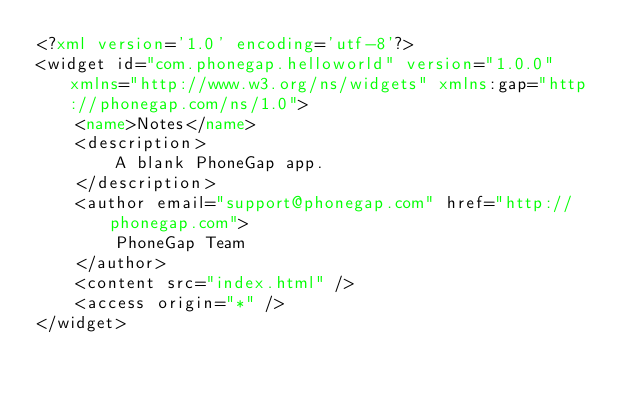Convert code to text. <code><loc_0><loc_0><loc_500><loc_500><_XML_><?xml version='1.0' encoding='utf-8'?>
<widget id="com.phonegap.helloworld" version="1.0.0" xmlns="http://www.w3.org/ns/widgets" xmlns:gap="http://phonegap.com/ns/1.0">
    <name>Notes</name>
    <description>
        A blank PhoneGap app.
    </description>
    <author email="support@phonegap.com" href="http://phonegap.com">
        PhoneGap Team
    </author>
    <content src="index.html" />
    <access origin="*" />
</widget>
</code> 